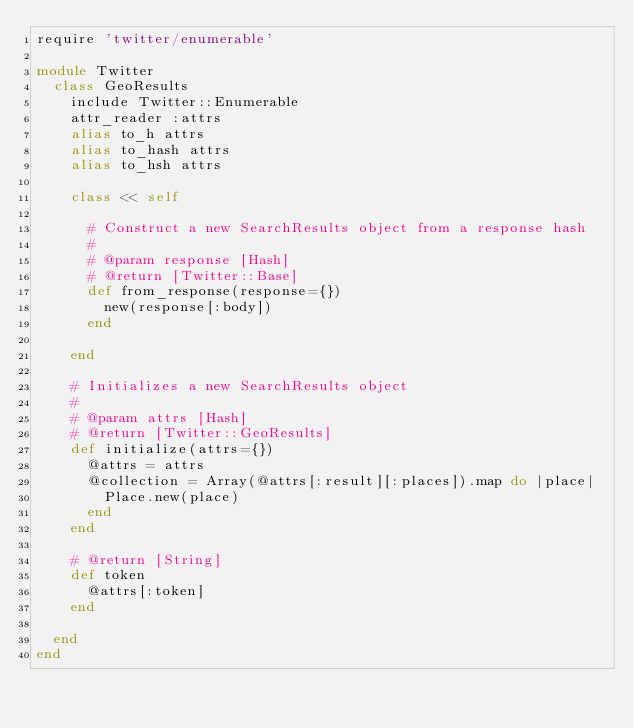<code> <loc_0><loc_0><loc_500><loc_500><_Ruby_>require 'twitter/enumerable'

module Twitter
  class GeoResults
    include Twitter::Enumerable
    attr_reader :attrs
    alias to_h attrs
    alias to_hash attrs
    alias to_hsh attrs

    class << self

      # Construct a new SearchResults object from a response hash
      #
      # @param response [Hash]
      # @return [Twitter::Base]
      def from_response(response={})
        new(response[:body])
      end

    end

    # Initializes a new SearchResults object
    #
    # @param attrs [Hash]
    # @return [Twitter::GeoResults]
    def initialize(attrs={})
      @attrs = attrs
      @collection = Array(@attrs[:result][:places]).map do |place|
        Place.new(place)
      end
    end

    # @return [String]
    def token
      @attrs[:token]
    end

  end
end
</code> 